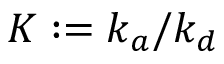<formula> <loc_0><loc_0><loc_500><loc_500>K \colon = k _ { a } / k _ { d }</formula> 